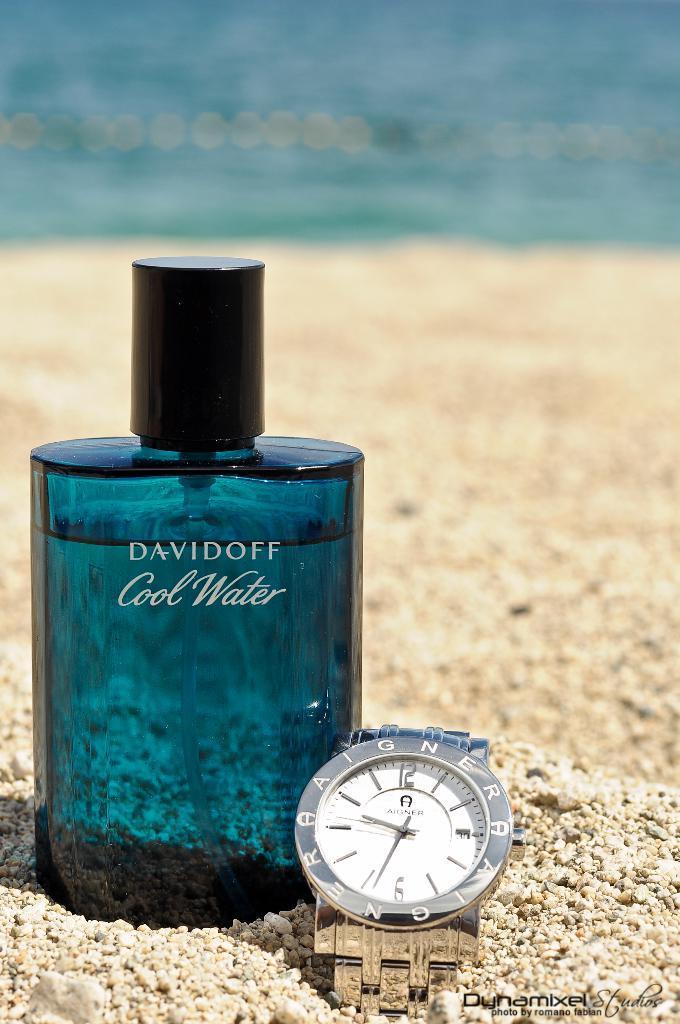How would you summarize this image in a sentence or two? In this image I can see a perfume bottle and a watch with some text written on it. In the background, I can see the sand and the water. 